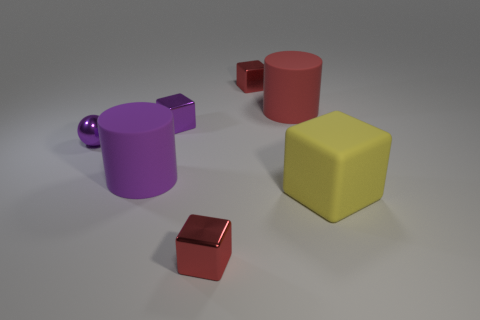Subtract all yellow rubber blocks. How many blocks are left? 3 Subtract all purple blocks. How many blocks are left? 3 Subtract all purple cubes. How many red spheres are left? 0 Subtract all yellow blocks. Subtract all big things. How many objects are left? 3 Add 5 purple matte cylinders. How many purple matte cylinders are left? 6 Add 1 blue cubes. How many blue cubes exist? 1 Add 1 small gray rubber things. How many objects exist? 8 Subtract 0 yellow cylinders. How many objects are left? 7 Subtract all cubes. How many objects are left? 3 Subtract 1 cylinders. How many cylinders are left? 1 